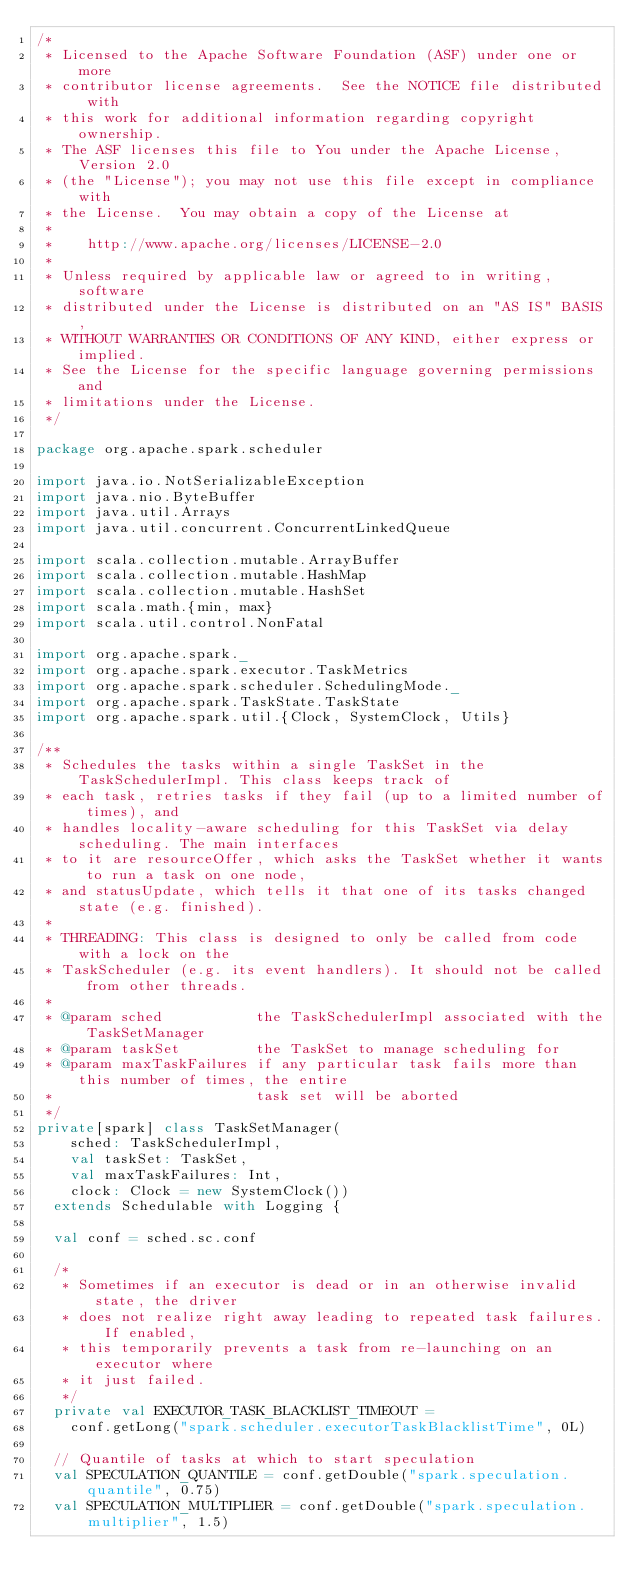<code> <loc_0><loc_0><loc_500><loc_500><_Scala_>/*
 * Licensed to the Apache Software Foundation (ASF) under one or more
 * contributor license agreements.  See the NOTICE file distributed with
 * this work for additional information regarding copyright ownership.
 * The ASF licenses this file to You under the Apache License, Version 2.0
 * (the "License"); you may not use this file except in compliance with
 * the License.  You may obtain a copy of the License at
 *
 *    http://www.apache.org/licenses/LICENSE-2.0
 *
 * Unless required by applicable law or agreed to in writing, software
 * distributed under the License is distributed on an "AS IS" BASIS,
 * WITHOUT WARRANTIES OR CONDITIONS OF ANY KIND, either express or implied.
 * See the License for the specific language governing permissions and
 * limitations under the License.
 */

package org.apache.spark.scheduler

import java.io.NotSerializableException
import java.nio.ByteBuffer
import java.util.Arrays
import java.util.concurrent.ConcurrentLinkedQueue

import scala.collection.mutable.ArrayBuffer
import scala.collection.mutable.HashMap
import scala.collection.mutable.HashSet
import scala.math.{min, max}
import scala.util.control.NonFatal

import org.apache.spark._
import org.apache.spark.executor.TaskMetrics
import org.apache.spark.scheduler.SchedulingMode._
import org.apache.spark.TaskState.TaskState
import org.apache.spark.util.{Clock, SystemClock, Utils}

/**
 * Schedules the tasks within a single TaskSet in the TaskSchedulerImpl. This class keeps track of
 * each task, retries tasks if they fail (up to a limited number of times), and
 * handles locality-aware scheduling for this TaskSet via delay scheduling. The main interfaces
 * to it are resourceOffer, which asks the TaskSet whether it wants to run a task on one node,
 * and statusUpdate, which tells it that one of its tasks changed state (e.g. finished).
 *
 * THREADING: This class is designed to only be called from code with a lock on the
 * TaskScheduler (e.g. its event handlers). It should not be called from other threads.
 *
 * @param sched           the TaskSchedulerImpl associated with the TaskSetManager
 * @param taskSet         the TaskSet to manage scheduling for
 * @param maxTaskFailures if any particular task fails more than this number of times, the entire
 *                        task set will be aborted
 */
private[spark] class TaskSetManager(
    sched: TaskSchedulerImpl,
    val taskSet: TaskSet,
    val maxTaskFailures: Int,
    clock: Clock = new SystemClock())
  extends Schedulable with Logging {

  val conf = sched.sc.conf

  /*
   * Sometimes if an executor is dead or in an otherwise invalid state, the driver
   * does not realize right away leading to repeated task failures. If enabled,
   * this temporarily prevents a task from re-launching on an executor where
   * it just failed.
   */
  private val EXECUTOR_TASK_BLACKLIST_TIMEOUT =
    conf.getLong("spark.scheduler.executorTaskBlacklistTime", 0L)

  // Quantile of tasks at which to start speculation
  val SPECULATION_QUANTILE = conf.getDouble("spark.speculation.quantile", 0.75)
  val SPECULATION_MULTIPLIER = conf.getDouble("spark.speculation.multiplier", 1.5)
</code> 